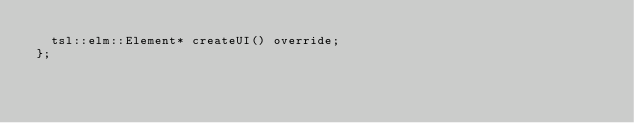Convert code to text. <code><loc_0><loc_0><loc_500><loc_500><_C++_>  tsl::elm::Element* createUI() override;
};
</code> 